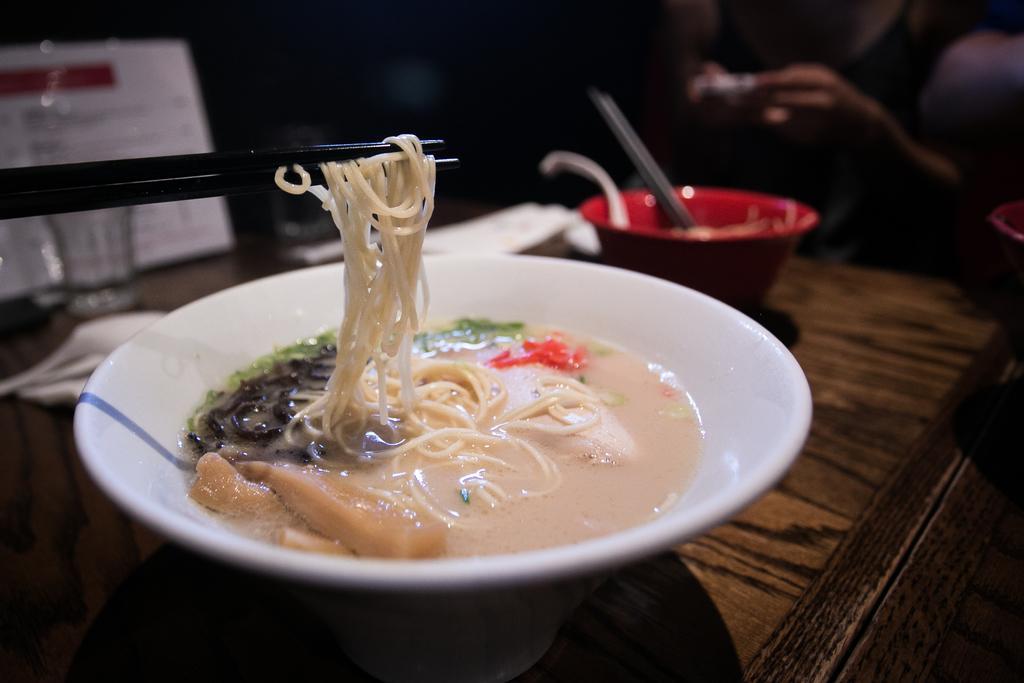How would you summarize this image in a sentence or two? Background is very dark and blur. Here we can see two bowls in red and white colour with a spoon. In white colour bowl we can see wet soft noodles. These are chopsticks. This is a table. Near to this bowl we can see a glass and a board. 